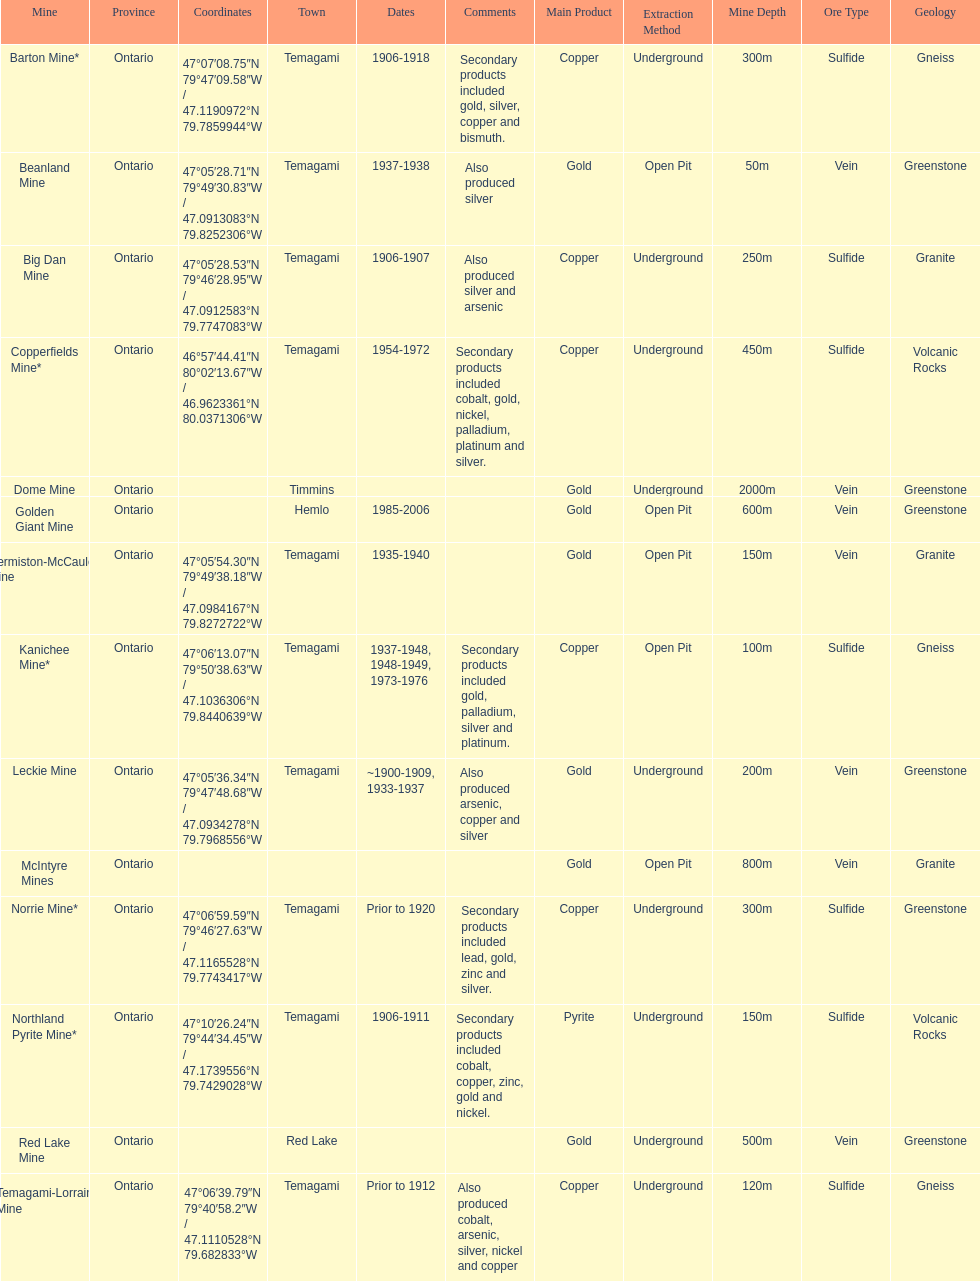What town is listed the most? Temagami. 